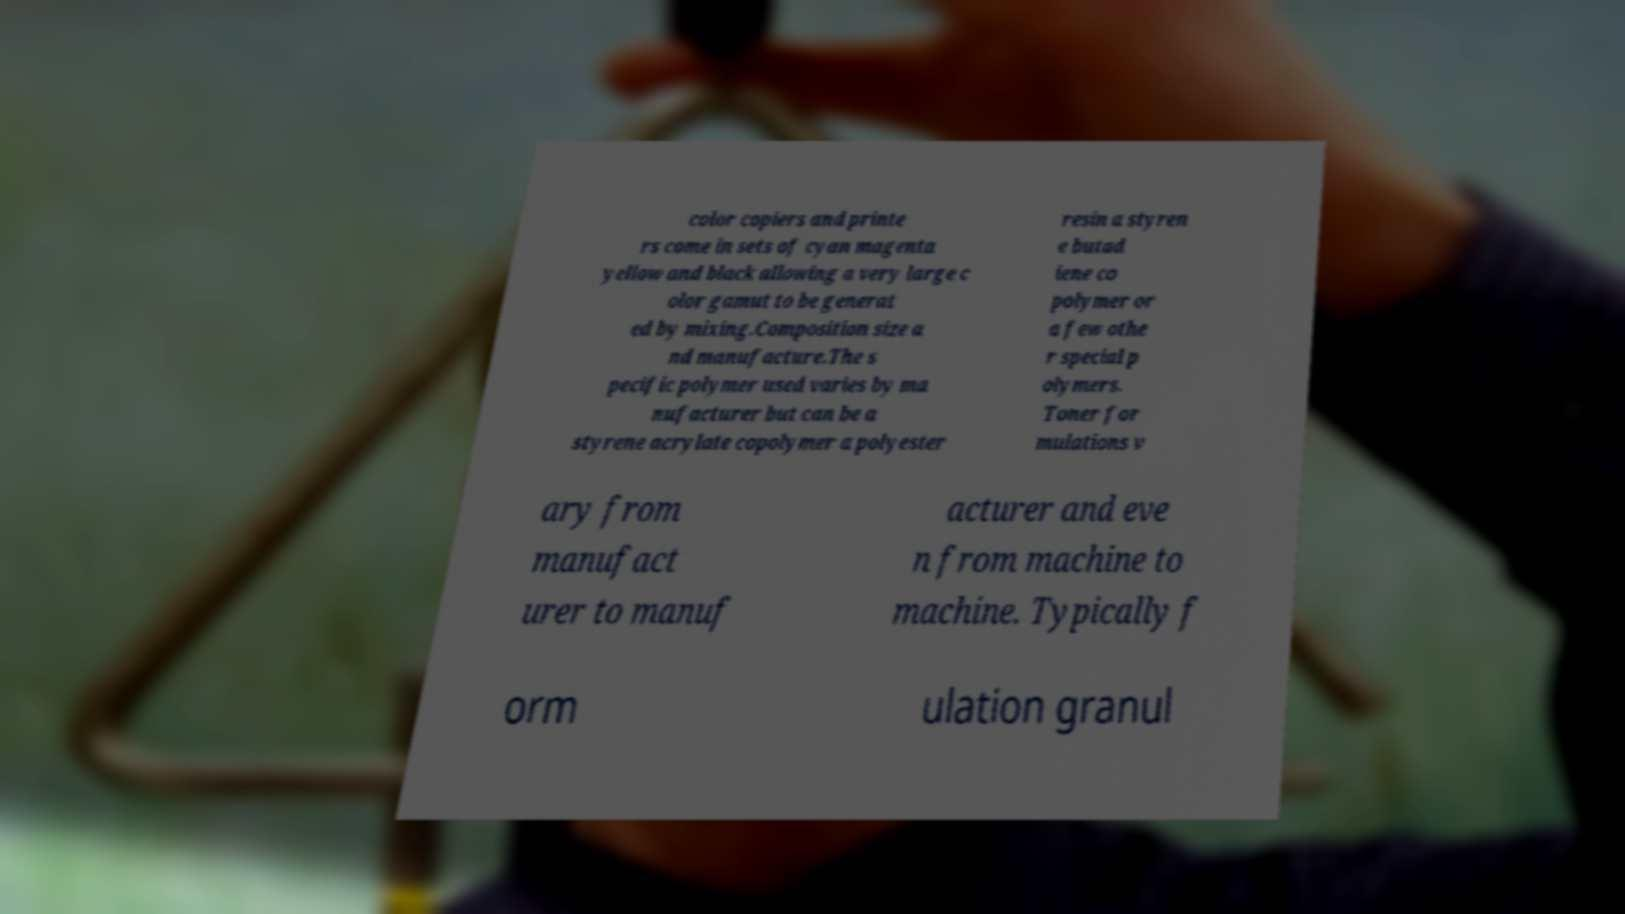There's text embedded in this image that I need extracted. Can you transcribe it verbatim? color copiers and printe rs come in sets of cyan magenta yellow and black allowing a very large c olor gamut to be generat ed by mixing.Composition size a nd manufacture.The s pecific polymer used varies by ma nufacturer but can be a styrene acrylate copolymer a polyester resin a styren e butad iene co polymer or a few othe r special p olymers. Toner for mulations v ary from manufact urer to manuf acturer and eve n from machine to machine. Typically f orm ulation granul 